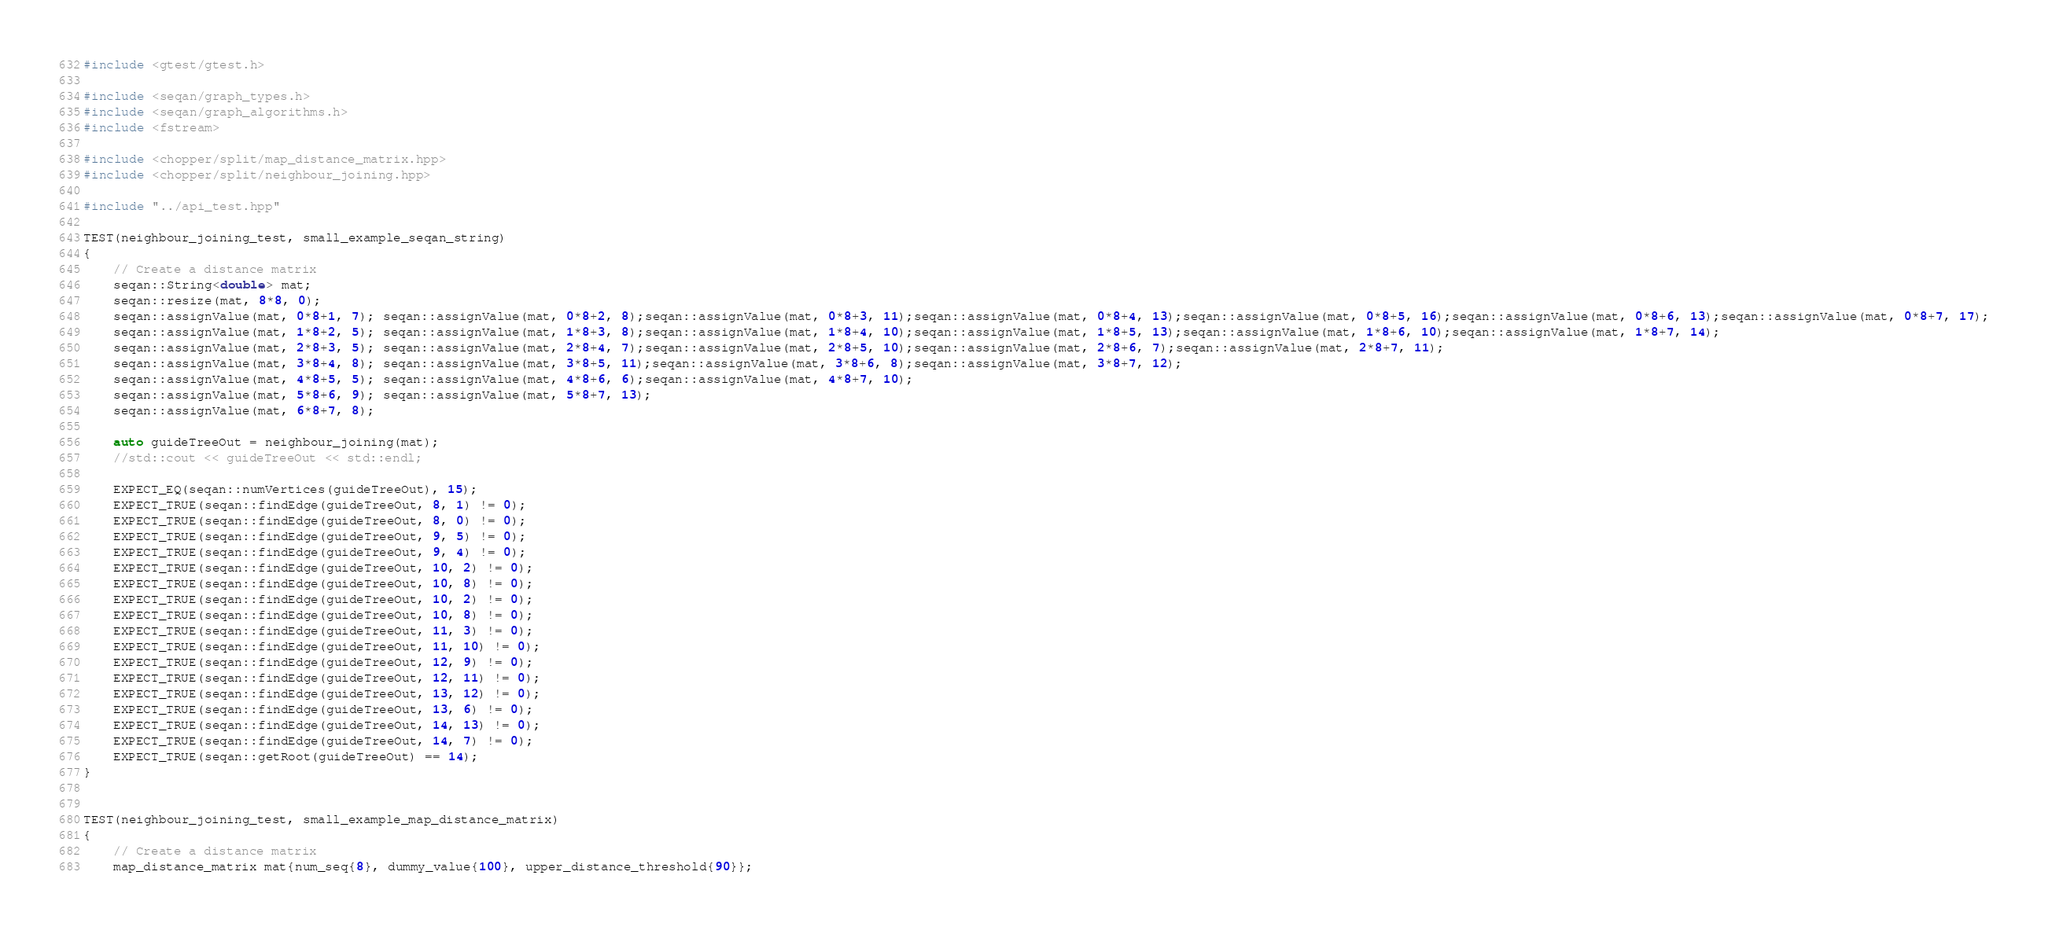<code> <loc_0><loc_0><loc_500><loc_500><_C++_>#include <gtest/gtest.h>

#include <seqan/graph_types.h>
#include <seqan/graph_algorithms.h>
#include <fstream>

#include <chopper/split/map_distance_matrix.hpp>
#include <chopper/split/neighbour_joining.hpp>

#include "../api_test.hpp"

TEST(neighbour_joining_test, small_example_seqan_string)
{
    // Create a distance matrix
    seqan::String<double> mat;
    seqan::resize(mat, 8*8, 0);
    seqan::assignValue(mat, 0*8+1, 7); seqan::assignValue(mat, 0*8+2, 8);seqan::assignValue(mat, 0*8+3, 11);seqan::assignValue(mat, 0*8+4, 13);seqan::assignValue(mat, 0*8+5, 16);seqan::assignValue(mat, 0*8+6, 13);seqan::assignValue(mat, 0*8+7, 17);
    seqan::assignValue(mat, 1*8+2, 5); seqan::assignValue(mat, 1*8+3, 8);seqan::assignValue(mat, 1*8+4, 10);seqan::assignValue(mat, 1*8+5, 13);seqan::assignValue(mat, 1*8+6, 10);seqan::assignValue(mat, 1*8+7, 14);
    seqan::assignValue(mat, 2*8+3, 5); seqan::assignValue(mat, 2*8+4, 7);seqan::assignValue(mat, 2*8+5, 10);seqan::assignValue(mat, 2*8+6, 7);seqan::assignValue(mat, 2*8+7, 11);
    seqan::assignValue(mat, 3*8+4, 8); seqan::assignValue(mat, 3*8+5, 11);seqan::assignValue(mat, 3*8+6, 8);seqan::assignValue(mat, 3*8+7, 12);
    seqan::assignValue(mat, 4*8+5, 5); seqan::assignValue(mat, 4*8+6, 6);seqan::assignValue(mat, 4*8+7, 10);
    seqan::assignValue(mat, 5*8+6, 9); seqan::assignValue(mat, 5*8+7, 13);
    seqan::assignValue(mat, 6*8+7, 8);

    auto guideTreeOut = neighbour_joining(mat);
    //std::cout << guideTreeOut << std::endl;

    EXPECT_EQ(seqan::numVertices(guideTreeOut), 15);
    EXPECT_TRUE(seqan::findEdge(guideTreeOut, 8, 1) != 0);
    EXPECT_TRUE(seqan::findEdge(guideTreeOut, 8, 0) != 0);
    EXPECT_TRUE(seqan::findEdge(guideTreeOut, 9, 5) != 0);
    EXPECT_TRUE(seqan::findEdge(guideTreeOut, 9, 4) != 0);
    EXPECT_TRUE(seqan::findEdge(guideTreeOut, 10, 2) != 0);
    EXPECT_TRUE(seqan::findEdge(guideTreeOut, 10, 8) != 0);
    EXPECT_TRUE(seqan::findEdge(guideTreeOut, 10, 2) != 0);
    EXPECT_TRUE(seqan::findEdge(guideTreeOut, 10, 8) != 0);
    EXPECT_TRUE(seqan::findEdge(guideTreeOut, 11, 3) != 0);
    EXPECT_TRUE(seqan::findEdge(guideTreeOut, 11, 10) != 0);
    EXPECT_TRUE(seqan::findEdge(guideTreeOut, 12, 9) != 0);
    EXPECT_TRUE(seqan::findEdge(guideTreeOut, 12, 11) != 0);
    EXPECT_TRUE(seqan::findEdge(guideTreeOut, 13, 12) != 0);
    EXPECT_TRUE(seqan::findEdge(guideTreeOut, 13, 6) != 0);
    EXPECT_TRUE(seqan::findEdge(guideTreeOut, 14, 13) != 0);
    EXPECT_TRUE(seqan::findEdge(guideTreeOut, 14, 7) != 0);
    EXPECT_TRUE(seqan::getRoot(guideTreeOut) == 14);
}


TEST(neighbour_joining_test, small_example_map_distance_matrix)
{
    // Create a distance matrix
    map_distance_matrix mat{num_seq{8}, dummy_value{100}, upper_distance_threshold{90}};
</code> 